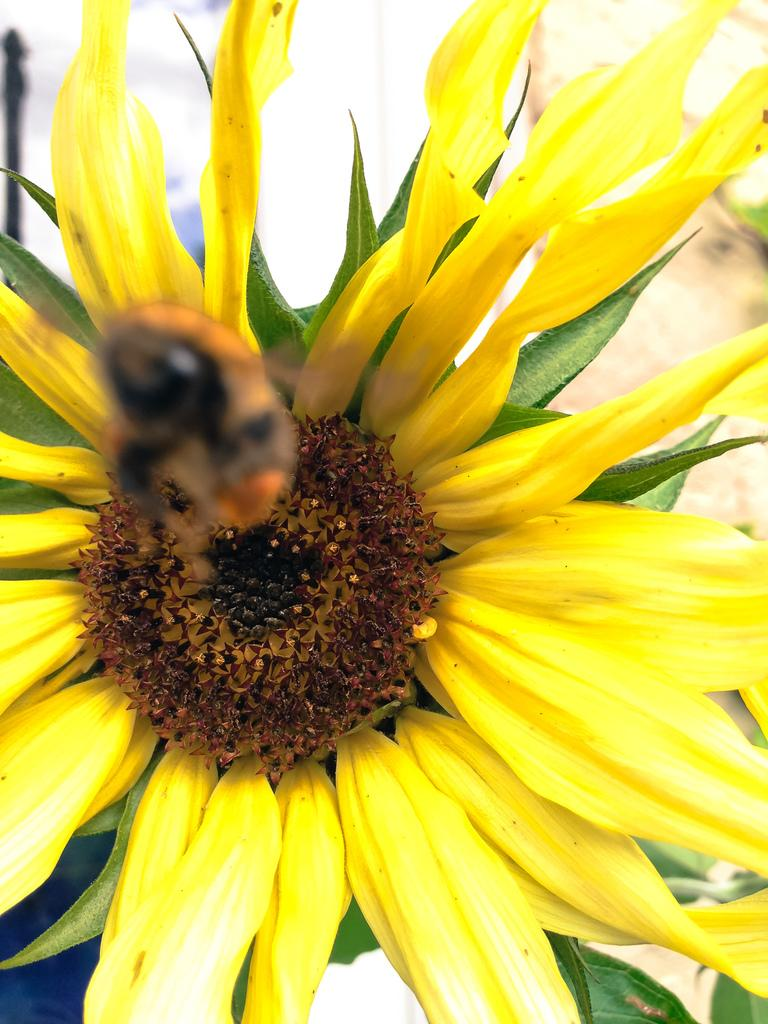What is present on the flower in the image? There is a bee on a flower in the image. What other elements can be seen in the image besides the bee and flower? There are leaves in the image. What type of design can be seen on the calculator in the image? There is no calculator present in the image. What type of furniture is visible in the image? There is no furniture, such as a sofa, present in the image. 